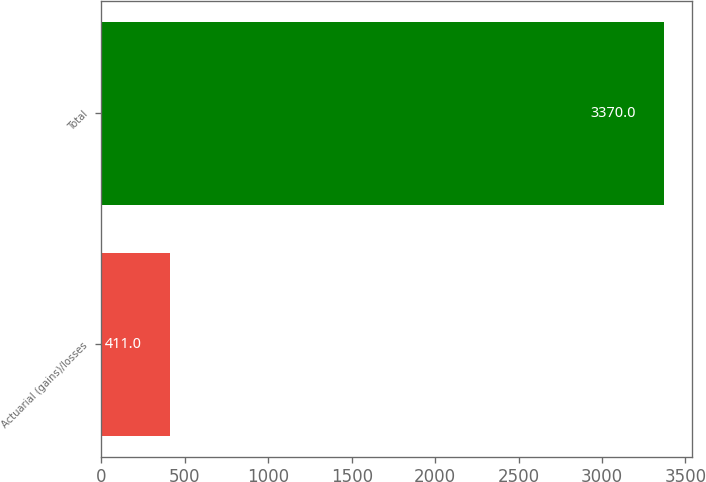<chart> <loc_0><loc_0><loc_500><loc_500><bar_chart><fcel>Actuarial (gains)/losses<fcel>Total<nl><fcel>411<fcel>3370<nl></chart> 